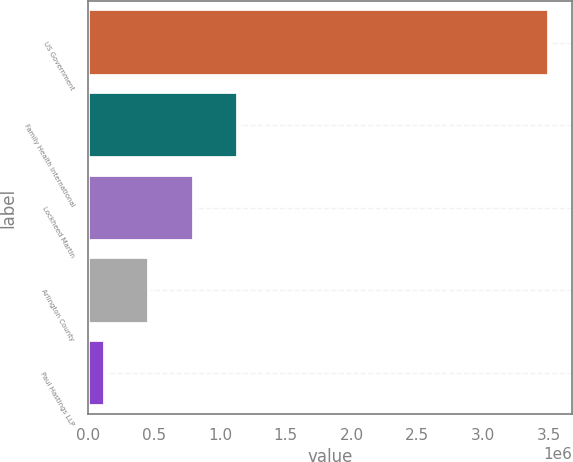Convert chart to OTSL. <chart><loc_0><loc_0><loc_500><loc_500><bar_chart><fcel>US Government<fcel>Family Health International<fcel>Lockheed Martin<fcel>Arlington County<fcel>Paul Hastings LLP<nl><fcel>3.505e+06<fcel>1.1397e+06<fcel>801800<fcel>463900<fcel>126000<nl></chart> 